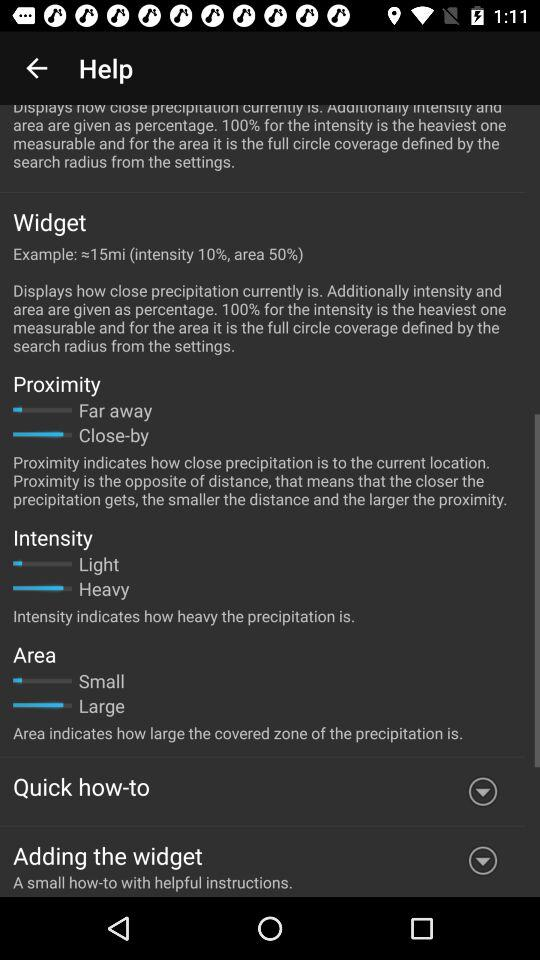How many items have arrows?
Answer the question using a single word or phrase. 2 